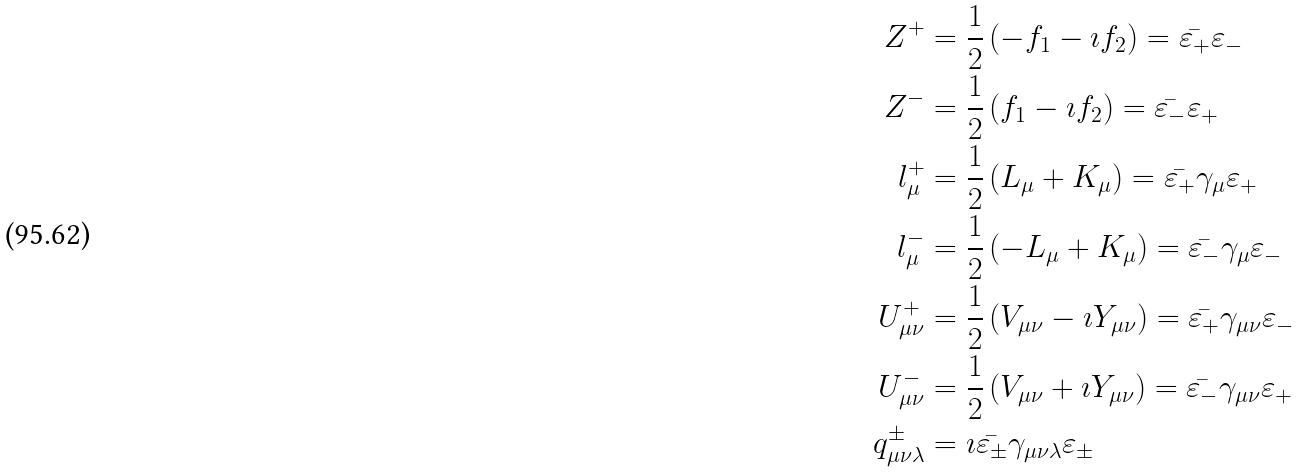Convert formula to latex. <formula><loc_0><loc_0><loc_500><loc_500>Z ^ { + } & = \frac { 1 } { 2 } \left ( - f _ { 1 } - \imath f _ { 2 } \right ) = \bar { \varepsilon _ { + } } \varepsilon _ { - } \\ Z ^ { - } & = \frac { 1 } { 2 } \left ( f _ { 1 } - \imath f _ { 2 } \right ) = \bar { \varepsilon _ { - } } \varepsilon _ { + } \\ l _ { \mu } ^ { + } & = \frac { 1 } { 2 } \left ( L _ { \mu } + K _ { \mu } \right ) = \bar { \varepsilon _ { + } } \gamma _ { \mu } \varepsilon _ { + } \\ l _ { \mu } ^ { - } & = \frac { 1 } { 2 } \left ( - L _ { \mu } + K _ { \mu } \right ) = \bar { \varepsilon _ { - } } \gamma _ { \mu } \varepsilon _ { - } \\ U _ { \mu \nu } ^ { + } & = \frac { 1 } { 2 } \left ( V _ { \mu \nu } - \imath Y _ { \mu \nu } \right ) = \bar { \varepsilon _ { + } } \gamma _ { \mu \nu } \varepsilon _ { - } \\ U _ { \mu \nu } ^ { - } & = \frac { 1 } { 2 } \left ( V _ { \mu \nu } + \imath Y _ { \mu \nu } \right ) = \bar { \varepsilon _ { - } } \gamma _ { \mu \nu } \varepsilon _ { + } \\ q _ { \mu \nu \lambda } ^ { \pm } & = \imath \bar { \varepsilon _ { \pm } } \gamma _ { \mu \nu \lambda } \varepsilon _ { \pm }</formula> 